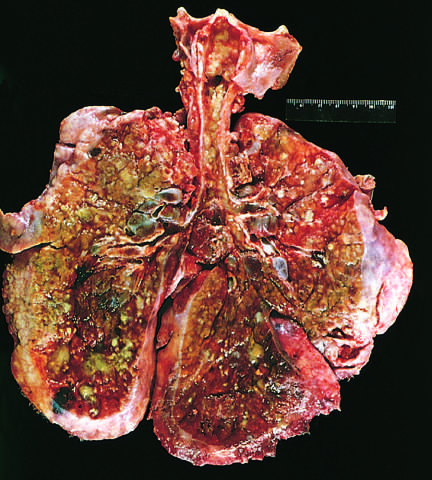re extensive mucous plugging and dilation of the tracheobronchial tree apparent?
Answer the question using a single word or phrase. Yes 